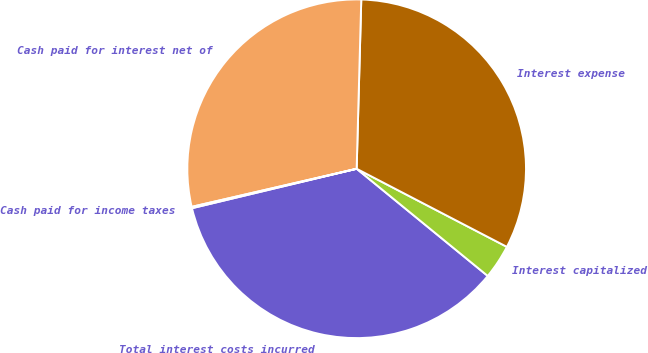<chart> <loc_0><loc_0><loc_500><loc_500><pie_chart><fcel>Total interest costs incurred<fcel>Interest capitalized<fcel>Interest expense<fcel>Cash paid for interest net of<fcel>Cash paid for income taxes<nl><fcel>35.34%<fcel>3.28%<fcel>32.19%<fcel>29.04%<fcel>0.13%<nl></chart> 